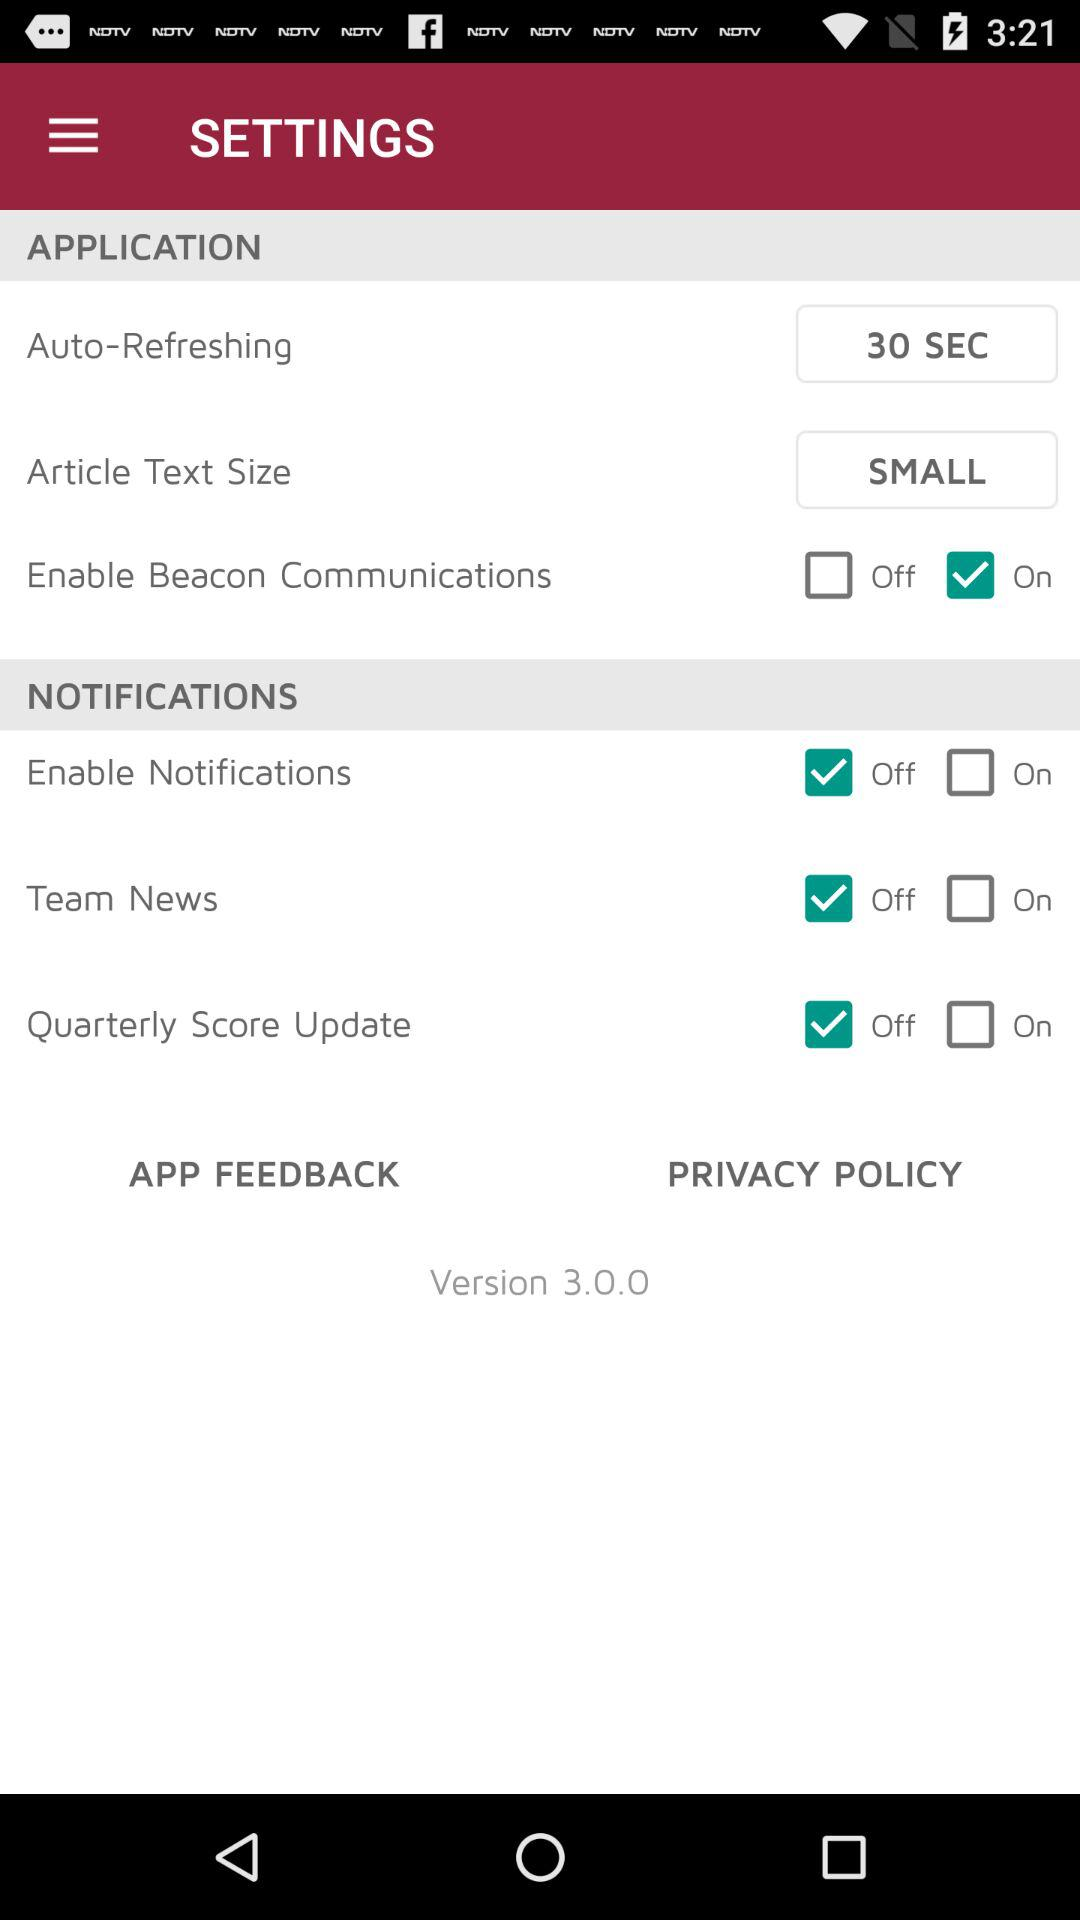What is the article text size? The article text size is small. 